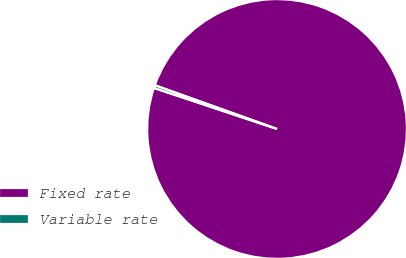<chart> <loc_0><loc_0><loc_500><loc_500><pie_chart><fcel>Fixed rate<fcel>Variable rate<nl><fcel>99.65%<fcel>0.35%<nl></chart> 